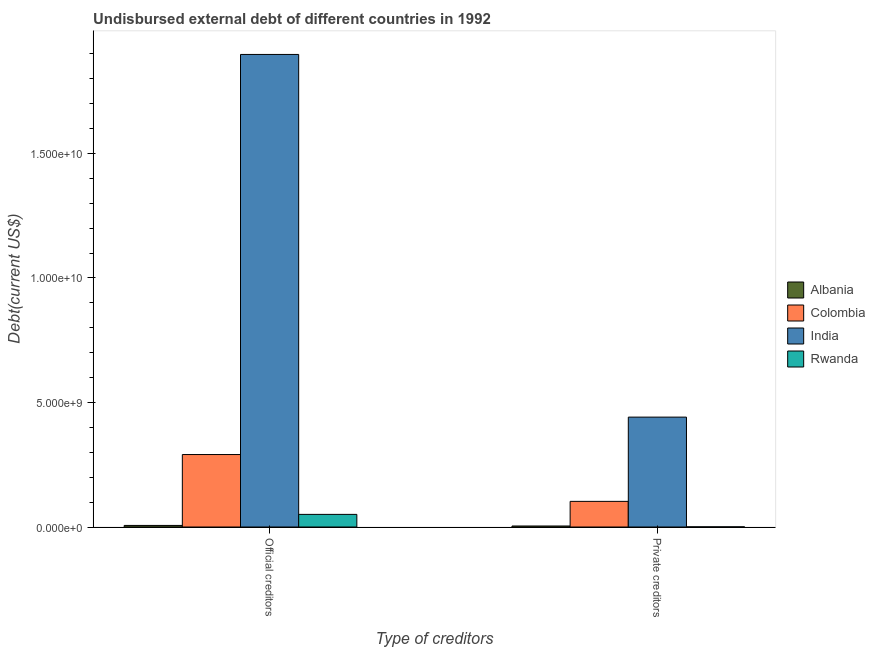How many groups of bars are there?
Offer a terse response. 2. Are the number of bars per tick equal to the number of legend labels?
Your answer should be very brief. Yes. How many bars are there on the 1st tick from the left?
Provide a short and direct response. 4. What is the label of the 2nd group of bars from the left?
Ensure brevity in your answer.  Private creditors. What is the undisbursed external debt of official creditors in Rwanda?
Give a very brief answer. 5.07e+08. Across all countries, what is the maximum undisbursed external debt of official creditors?
Offer a very short reply. 1.90e+1. Across all countries, what is the minimum undisbursed external debt of private creditors?
Provide a succinct answer. 6.66e+06. In which country was the undisbursed external debt of private creditors minimum?
Your answer should be very brief. Rwanda. What is the total undisbursed external debt of official creditors in the graph?
Your answer should be very brief. 2.25e+1. What is the difference between the undisbursed external debt of private creditors in Albania and that in Rwanda?
Make the answer very short. 3.40e+07. What is the difference between the undisbursed external debt of private creditors in Albania and the undisbursed external debt of official creditors in Rwanda?
Your response must be concise. -4.66e+08. What is the average undisbursed external debt of official creditors per country?
Make the answer very short. 5.61e+09. What is the difference between the undisbursed external debt of private creditors and undisbursed external debt of official creditors in Albania?
Provide a succinct answer. -2.32e+07. In how many countries, is the undisbursed external debt of private creditors greater than 9000000000 US$?
Your answer should be compact. 0. What is the ratio of the undisbursed external debt of private creditors in India to that in Albania?
Provide a succinct answer. 108.49. In how many countries, is the undisbursed external debt of private creditors greater than the average undisbursed external debt of private creditors taken over all countries?
Provide a succinct answer. 1. What does the 1st bar from the left in Official creditors represents?
Offer a very short reply. Albania. Are all the bars in the graph horizontal?
Your answer should be compact. No. How many countries are there in the graph?
Keep it short and to the point. 4. Are the values on the major ticks of Y-axis written in scientific E-notation?
Provide a succinct answer. Yes. Where does the legend appear in the graph?
Offer a very short reply. Center right. How many legend labels are there?
Offer a very short reply. 4. What is the title of the graph?
Offer a terse response. Undisbursed external debt of different countries in 1992. Does "Turkmenistan" appear as one of the legend labels in the graph?
Keep it short and to the point. No. What is the label or title of the X-axis?
Provide a short and direct response. Type of creditors. What is the label or title of the Y-axis?
Make the answer very short. Debt(current US$). What is the Debt(current US$) of Albania in Official creditors?
Your response must be concise. 6.38e+07. What is the Debt(current US$) of Colombia in Official creditors?
Provide a short and direct response. 2.91e+09. What is the Debt(current US$) in India in Official creditors?
Ensure brevity in your answer.  1.90e+1. What is the Debt(current US$) in Rwanda in Official creditors?
Ensure brevity in your answer.  5.07e+08. What is the Debt(current US$) in Albania in Private creditors?
Make the answer very short. 4.07e+07. What is the Debt(current US$) of Colombia in Private creditors?
Ensure brevity in your answer.  1.03e+09. What is the Debt(current US$) of India in Private creditors?
Your response must be concise. 4.41e+09. What is the Debt(current US$) of Rwanda in Private creditors?
Ensure brevity in your answer.  6.66e+06. Across all Type of creditors, what is the maximum Debt(current US$) of Albania?
Your answer should be compact. 6.38e+07. Across all Type of creditors, what is the maximum Debt(current US$) of Colombia?
Provide a short and direct response. 2.91e+09. Across all Type of creditors, what is the maximum Debt(current US$) in India?
Your answer should be very brief. 1.90e+1. Across all Type of creditors, what is the maximum Debt(current US$) in Rwanda?
Your answer should be compact. 5.07e+08. Across all Type of creditors, what is the minimum Debt(current US$) in Albania?
Provide a succinct answer. 4.07e+07. Across all Type of creditors, what is the minimum Debt(current US$) of Colombia?
Keep it short and to the point. 1.03e+09. Across all Type of creditors, what is the minimum Debt(current US$) in India?
Your answer should be compact. 4.41e+09. Across all Type of creditors, what is the minimum Debt(current US$) in Rwanda?
Your response must be concise. 6.66e+06. What is the total Debt(current US$) of Albania in the graph?
Provide a short and direct response. 1.05e+08. What is the total Debt(current US$) of Colombia in the graph?
Keep it short and to the point. 3.94e+09. What is the total Debt(current US$) of India in the graph?
Give a very brief answer. 2.34e+1. What is the total Debt(current US$) of Rwanda in the graph?
Provide a succinct answer. 5.13e+08. What is the difference between the Debt(current US$) in Albania in Official creditors and that in Private creditors?
Make the answer very short. 2.32e+07. What is the difference between the Debt(current US$) of Colombia in Official creditors and that in Private creditors?
Offer a very short reply. 1.88e+09. What is the difference between the Debt(current US$) in India in Official creditors and that in Private creditors?
Your answer should be compact. 1.46e+1. What is the difference between the Debt(current US$) of Rwanda in Official creditors and that in Private creditors?
Offer a very short reply. 5.00e+08. What is the difference between the Debt(current US$) of Albania in Official creditors and the Debt(current US$) of Colombia in Private creditors?
Provide a succinct answer. -9.66e+08. What is the difference between the Debt(current US$) in Albania in Official creditors and the Debt(current US$) in India in Private creditors?
Offer a terse response. -4.35e+09. What is the difference between the Debt(current US$) in Albania in Official creditors and the Debt(current US$) in Rwanda in Private creditors?
Give a very brief answer. 5.72e+07. What is the difference between the Debt(current US$) in Colombia in Official creditors and the Debt(current US$) in India in Private creditors?
Your answer should be compact. -1.50e+09. What is the difference between the Debt(current US$) of Colombia in Official creditors and the Debt(current US$) of Rwanda in Private creditors?
Offer a terse response. 2.90e+09. What is the difference between the Debt(current US$) in India in Official creditors and the Debt(current US$) in Rwanda in Private creditors?
Your answer should be compact. 1.90e+1. What is the average Debt(current US$) in Albania per Type of creditors?
Your response must be concise. 5.23e+07. What is the average Debt(current US$) of Colombia per Type of creditors?
Ensure brevity in your answer.  1.97e+09. What is the average Debt(current US$) of India per Type of creditors?
Keep it short and to the point. 1.17e+1. What is the average Debt(current US$) of Rwanda per Type of creditors?
Keep it short and to the point. 2.57e+08. What is the difference between the Debt(current US$) of Albania and Debt(current US$) of Colombia in Official creditors?
Provide a succinct answer. -2.85e+09. What is the difference between the Debt(current US$) in Albania and Debt(current US$) in India in Official creditors?
Provide a succinct answer. -1.89e+1. What is the difference between the Debt(current US$) of Albania and Debt(current US$) of Rwanda in Official creditors?
Offer a very short reply. -4.43e+08. What is the difference between the Debt(current US$) of Colombia and Debt(current US$) of India in Official creditors?
Your answer should be compact. -1.61e+1. What is the difference between the Debt(current US$) of Colombia and Debt(current US$) of Rwanda in Official creditors?
Provide a short and direct response. 2.40e+09. What is the difference between the Debt(current US$) in India and Debt(current US$) in Rwanda in Official creditors?
Your answer should be very brief. 1.85e+1. What is the difference between the Debt(current US$) in Albania and Debt(current US$) in Colombia in Private creditors?
Your answer should be very brief. -9.89e+08. What is the difference between the Debt(current US$) of Albania and Debt(current US$) of India in Private creditors?
Keep it short and to the point. -4.37e+09. What is the difference between the Debt(current US$) of Albania and Debt(current US$) of Rwanda in Private creditors?
Your answer should be very brief. 3.40e+07. What is the difference between the Debt(current US$) of Colombia and Debt(current US$) of India in Private creditors?
Provide a short and direct response. -3.38e+09. What is the difference between the Debt(current US$) in Colombia and Debt(current US$) in Rwanda in Private creditors?
Your answer should be compact. 1.02e+09. What is the difference between the Debt(current US$) in India and Debt(current US$) in Rwanda in Private creditors?
Offer a terse response. 4.41e+09. What is the ratio of the Debt(current US$) of Albania in Official creditors to that in Private creditors?
Your response must be concise. 1.57. What is the ratio of the Debt(current US$) in Colombia in Official creditors to that in Private creditors?
Offer a very short reply. 2.83. What is the ratio of the Debt(current US$) in India in Official creditors to that in Private creditors?
Offer a terse response. 4.3. What is the ratio of the Debt(current US$) in Rwanda in Official creditors to that in Private creditors?
Give a very brief answer. 76.08. What is the difference between the highest and the second highest Debt(current US$) in Albania?
Make the answer very short. 2.32e+07. What is the difference between the highest and the second highest Debt(current US$) in Colombia?
Offer a terse response. 1.88e+09. What is the difference between the highest and the second highest Debt(current US$) of India?
Your answer should be compact. 1.46e+1. What is the difference between the highest and the second highest Debt(current US$) of Rwanda?
Provide a succinct answer. 5.00e+08. What is the difference between the highest and the lowest Debt(current US$) in Albania?
Ensure brevity in your answer.  2.32e+07. What is the difference between the highest and the lowest Debt(current US$) of Colombia?
Keep it short and to the point. 1.88e+09. What is the difference between the highest and the lowest Debt(current US$) in India?
Keep it short and to the point. 1.46e+1. What is the difference between the highest and the lowest Debt(current US$) in Rwanda?
Your answer should be compact. 5.00e+08. 